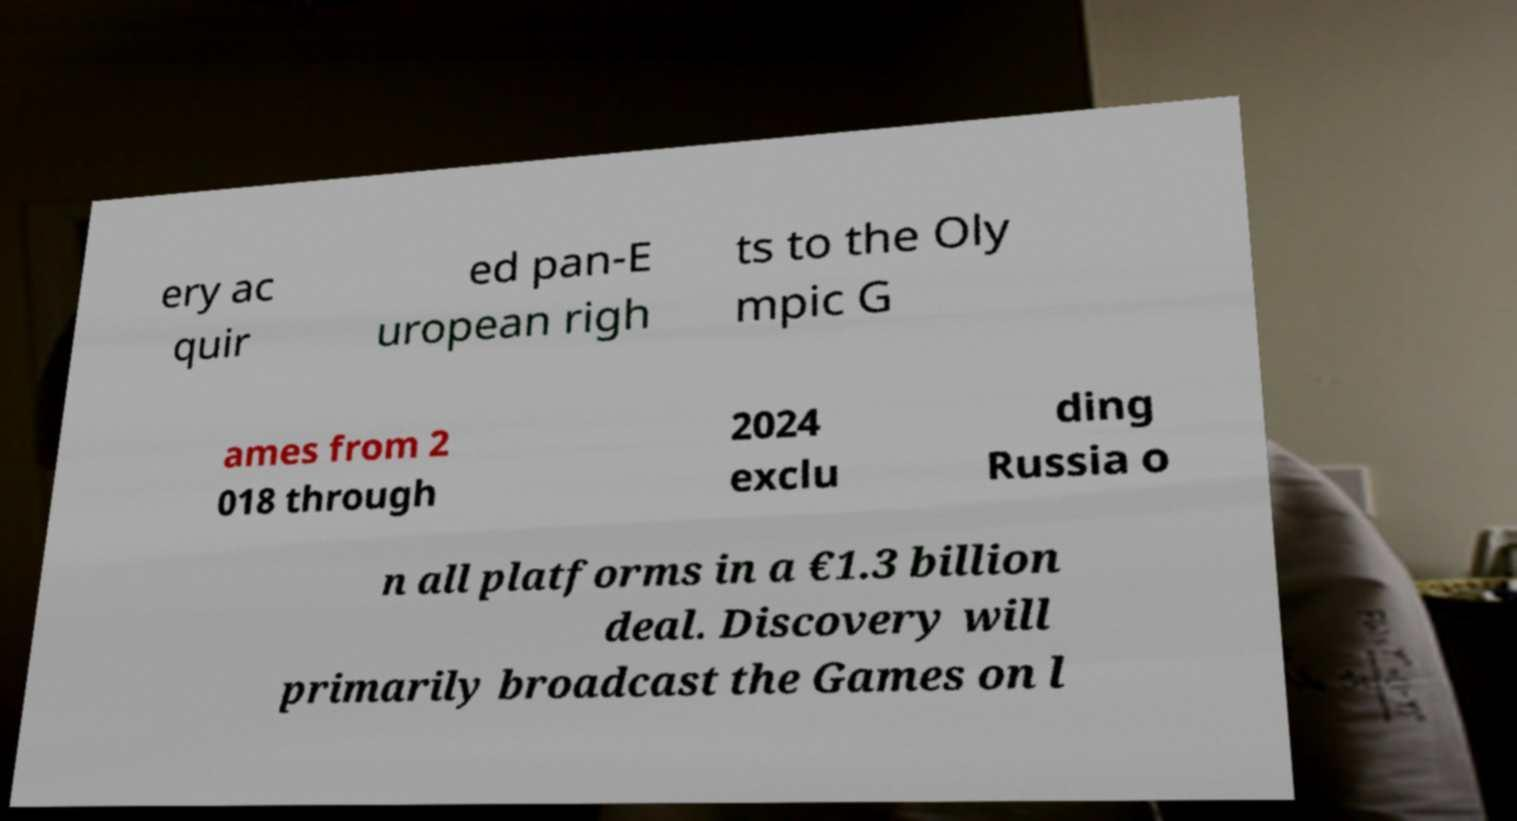I need the written content from this picture converted into text. Can you do that? ery ac quir ed pan-E uropean righ ts to the Oly mpic G ames from 2 018 through 2024 exclu ding Russia o n all platforms in a €1.3 billion deal. Discovery will primarily broadcast the Games on l 